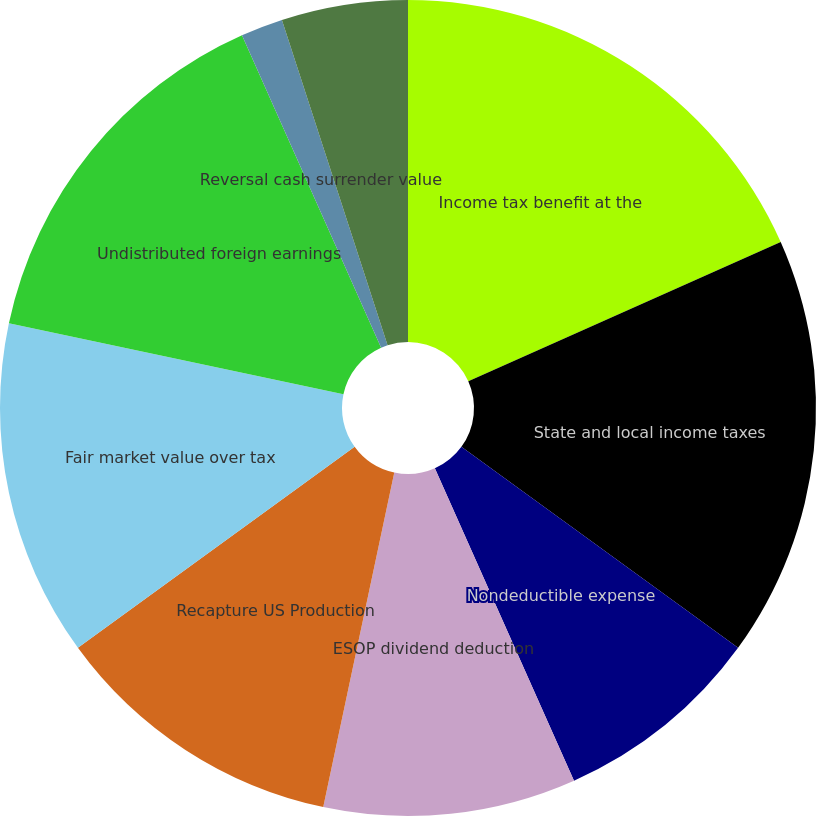Convert chart to OTSL. <chart><loc_0><loc_0><loc_500><loc_500><pie_chart><fcel>Income tax benefit at the<fcel>State and local income taxes<fcel>Nondeductible expense<fcel>ESOP dividend deduction<fcel>Recapture US Production<fcel>Fair market value over tax<fcel>Undistributed foreign earnings<fcel>Tax loss on sale of stock -<fcel>Reversal cash surrender value<fcel>Prior year true up adjustments<nl><fcel>18.33%<fcel>16.67%<fcel>8.33%<fcel>10.0%<fcel>11.67%<fcel>13.33%<fcel>15.0%<fcel>0.0%<fcel>1.67%<fcel>5.0%<nl></chart> 